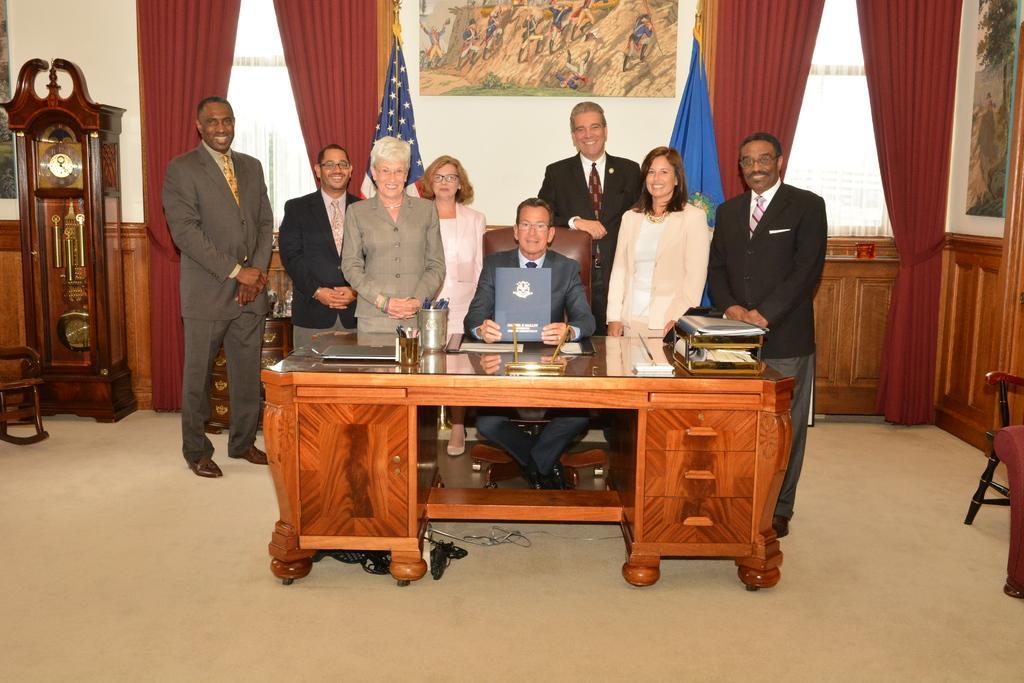In one or two sentences, can you explain what this image depicts? There is a floor ,and a table of brown color ,on that table there are some books ,laptop,and a pen holder and a man holding a book ,some people are standing and in the background there is wall and curtains and a picture on the wall and beside the right side of the table there is a chair. 